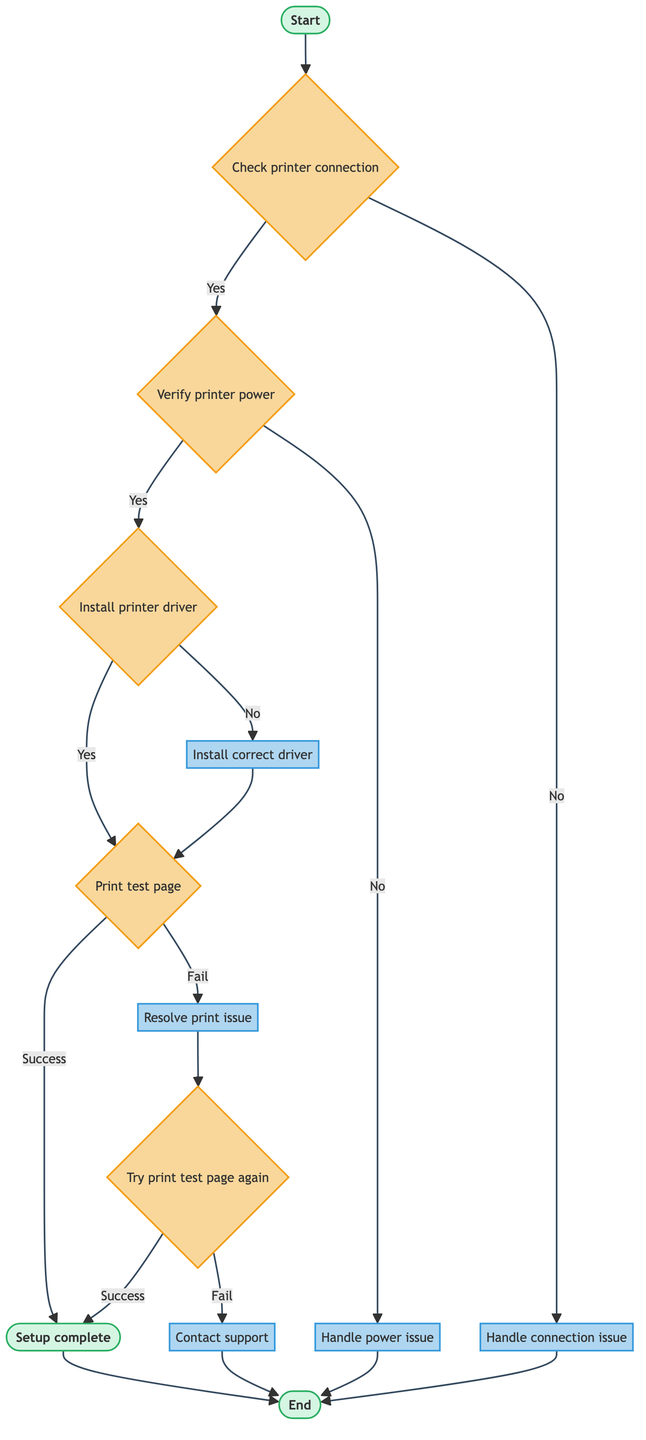what is the starting point of the flowchart? The flowchart begins at the node labeled "Start," which is represented as "start_process."
Answer: start_process how many main steps are there in the diagram? There are seven main steps represented as unique nodes before reaching the end of the process.
Answer: seven what happens when the printer is not physically connected? If the printer is not physically connected, the flowchart leads to the action node labeled "Handle connection issue."
Answer: Handle connection issue what is the subsequent action after "Install correct driver"? The next action following "Install correct driver" is to execute the "Print test page."
Answer: Print test page what is the final outcome if the test page prints successfully? If the test page prints successfully, the outcome is labeled as "Setup complete."
Answer: Setup complete which step provides guidance for resolving common print issues? The step that guides users through resolving common print issues is "Resolve print issue."
Answer: Resolve print issue if the printer is powered off, which action is taken next? If the printer is powered off, the next action is labeled "Handle power issue."
Answer: Handle power issue how do you proceed after resolving a print issue? After resolving a print issue, the next step is to "Try print test page again."
Answer: Try print test page again what is the flowchart's endpoint? The flowchart concludes at the node labeled "End," represented as "end_process."
Answer: end_process 